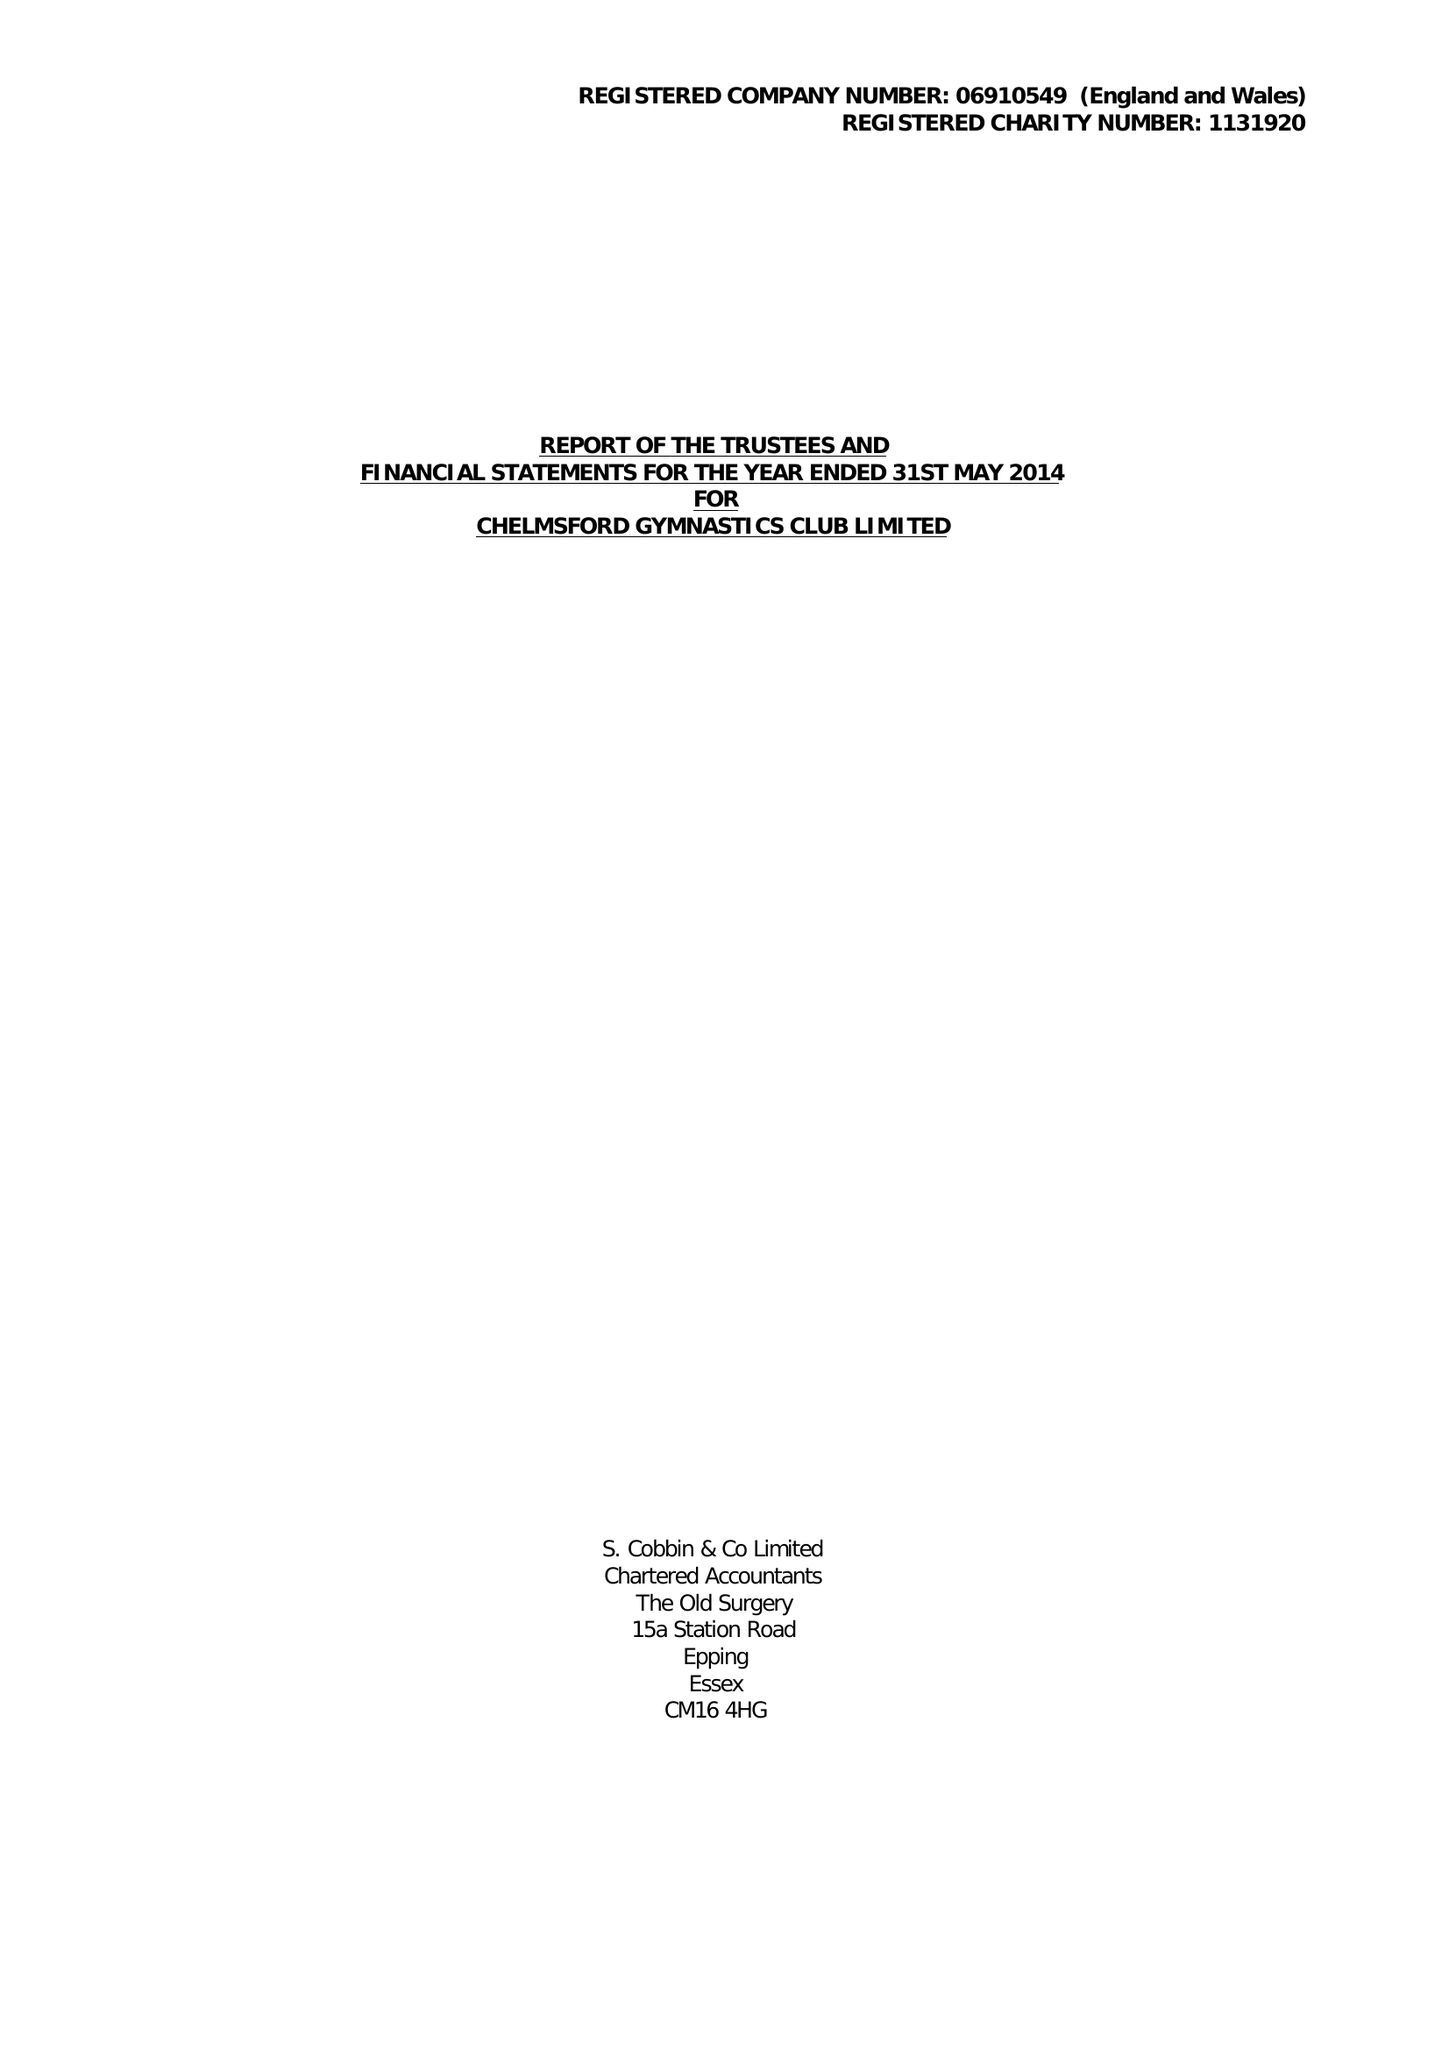What is the value for the address__post_town?
Answer the question using a single word or phrase. CHELMSFORD 